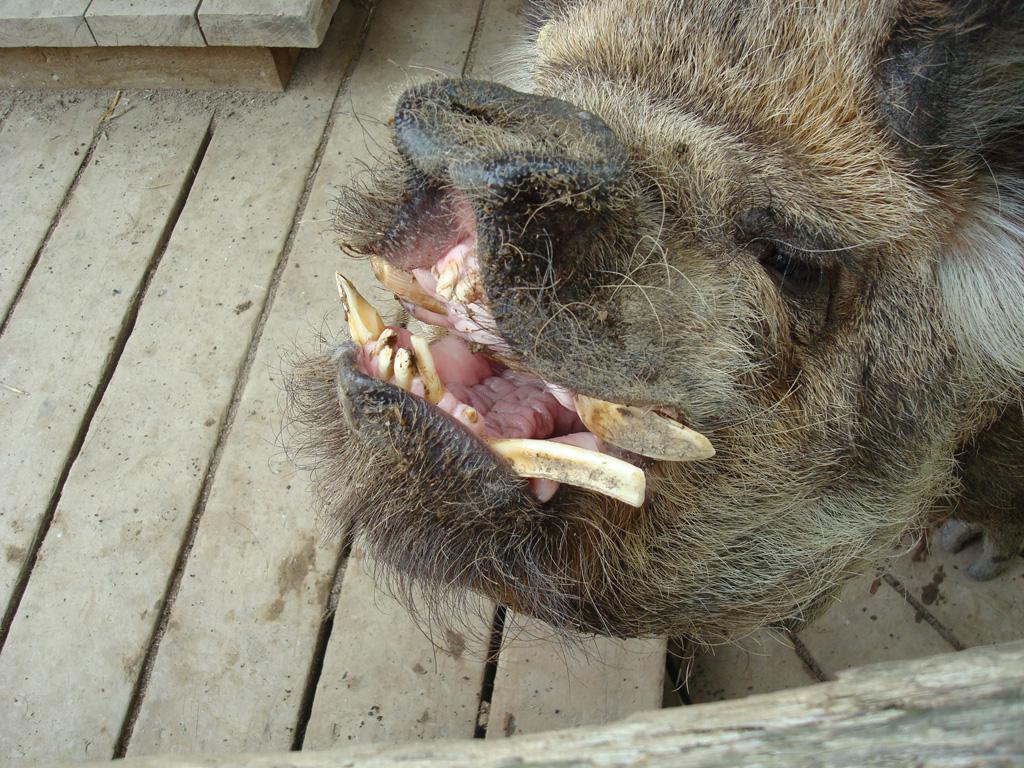How would you summarize this image in a sentence or two? In this image, we can see an animal on the wooden surface. 